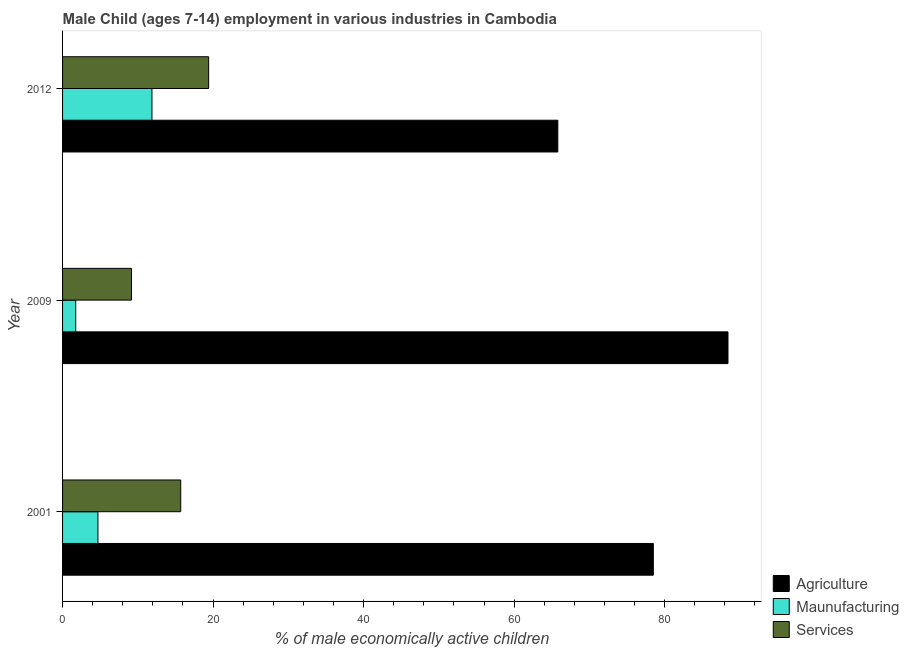How many different coloured bars are there?
Your answer should be very brief. 3. Are the number of bars on each tick of the Y-axis equal?
Make the answer very short. Yes. How many bars are there on the 2nd tick from the top?
Make the answer very short. 3. How many bars are there on the 1st tick from the bottom?
Your answer should be compact. 3. In how many cases, is the number of bars for a given year not equal to the number of legend labels?
Provide a short and direct response. 0. What is the percentage of economically active children in services in 2009?
Your answer should be very brief. 9.16. Across all years, what is the maximum percentage of economically active children in agriculture?
Keep it short and to the point. 88.42. Across all years, what is the minimum percentage of economically active children in services?
Offer a terse response. 9.16. What is the total percentage of economically active children in services in the graph?
Offer a very short reply. 44.27. What is the difference between the percentage of economically active children in manufacturing in 2001 and that in 2012?
Your response must be concise. -7.18. What is the difference between the percentage of economically active children in manufacturing in 2001 and the percentage of economically active children in services in 2009?
Provide a succinct answer. -4.46. What is the average percentage of economically active children in agriculture per year?
Provide a short and direct response. 77.58. In the year 2009, what is the difference between the percentage of economically active children in manufacturing and percentage of economically active children in agriculture?
Your answer should be very brief. -86.67. In how many years, is the percentage of economically active children in manufacturing greater than 32 %?
Make the answer very short. 0. What is the ratio of the percentage of economically active children in agriculture in 2001 to that in 2012?
Your response must be concise. 1.19. Is the percentage of economically active children in agriculture in 2001 less than that in 2009?
Your response must be concise. Yes. Is the difference between the percentage of economically active children in services in 2009 and 2012 greater than the difference between the percentage of economically active children in agriculture in 2009 and 2012?
Ensure brevity in your answer.  No. What is the difference between the highest and the second highest percentage of economically active children in services?
Your answer should be very brief. 3.71. What is the difference between the highest and the lowest percentage of economically active children in manufacturing?
Keep it short and to the point. 10.13. In how many years, is the percentage of economically active children in manufacturing greater than the average percentage of economically active children in manufacturing taken over all years?
Your answer should be compact. 1. Is the sum of the percentage of economically active children in services in 2001 and 2009 greater than the maximum percentage of economically active children in agriculture across all years?
Ensure brevity in your answer.  No. What does the 1st bar from the top in 2001 represents?
Keep it short and to the point. Services. What does the 2nd bar from the bottom in 2012 represents?
Provide a short and direct response. Maunufacturing. How many bars are there?
Offer a terse response. 9. Are all the bars in the graph horizontal?
Keep it short and to the point. Yes. Are the values on the major ticks of X-axis written in scientific E-notation?
Offer a very short reply. No. Does the graph contain any zero values?
Make the answer very short. No. Does the graph contain grids?
Give a very brief answer. No. Where does the legend appear in the graph?
Make the answer very short. Bottom right. How are the legend labels stacked?
Your answer should be compact. Vertical. What is the title of the graph?
Your response must be concise. Male Child (ages 7-14) employment in various industries in Cambodia. What is the label or title of the X-axis?
Offer a terse response. % of male economically active children. What is the label or title of the Y-axis?
Keep it short and to the point. Year. What is the % of male economically active children in Agriculture in 2001?
Your answer should be very brief. 78.5. What is the % of male economically active children of Agriculture in 2009?
Your answer should be very brief. 88.42. What is the % of male economically active children of Maunufacturing in 2009?
Offer a terse response. 1.75. What is the % of male economically active children in Services in 2009?
Provide a succinct answer. 9.16. What is the % of male economically active children of Agriculture in 2012?
Give a very brief answer. 65.81. What is the % of male economically active children of Maunufacturing in 2012?
Provide a short and direct response. 11.88. What is the % of male economically active children in Services in 2012?
Provide a short and direct response. 19.41. Across all years, what is the maximum % of male economically active children of Agriculture?
Ensure brevity in your answer.  88.42. Across all years, what is the maximum % of male economically active children in Maunufacturing?
Provide a short and direct response. 11.88. Across all years, what is the maximum % of male economically active children in Services?
Give a very brief answer. 19.41. Across all years, what is the minimum % of male economically active children in Agriculture?
Provide a succinct answer. 65.81. Across all years, what is the minimum % of male economically active children of Maunufacturing?
Make the answer very short. 1.75. Across all years, what is the minimum % of male economically active children of Services?
Give a very brief answer. 9.16. What is the total % of male economically active children in Agriculture in the graph?
Your response must be concise. 232.73. What is the total % of male economically active children in Maunufacturing in the graph?
Provide a succinct answer. 18.33. What is the total % of male economically active children of Services in the graph?
Provide a succinct answer. 44.27. What is the difference between the % of male economically active children of Agriculture in 2001 and that in 2009?
Your response must be concise. -9.92. What is the difference between the % of male economically active children in Maunufacturing in 2001 and that in 2009?
Ensure brevity in your answer.  2.95. What is the difference between the % of male economically active children of Services in 2001 and that in 2009?
Your response must be concise. 6.54. What is the difference between the % of male economically active children of Agriculture in 2001 and that in 2012?
Offer a terse response. 12.69. What is the difference between the % of male economically active children in Maunufacturing in 2001 and that in 2012?
Keep it short and to the point. -7.18. What is the difference between the % of male economically active children in Services in 2001 and that in 2012?
Make the answer very short. -3.71. What is the difference between the % of male economically active children of Agriculture in 2009 and that in 2012?
Offer a very short reply. 22.61. What is the difference between the % of male economically active children in Maunufacturing in 2009 and that in 2012?
Provide a short and direct response. -10.13. What is the difference between the % of male economically active children of Services in 2009 and that in 2012?
Offer a very short reply. -10.25. What is the difference between the % of male economically active children in Agriculture in 2001 and the % of male economically active children in Maunufacturing in 2009?
Keep it short and to the point. 76.75. What is the difference between the % of male economically active children in Agriculture in 2001 and the % of male economically active children in Services in 2009?
Give a very brief answer. 69.34. What is the difference between the % of male economically active children of Maunufacturing in 2001 and the % of male economically active children of Services in 2009?
Ensure brevity in your answer.  -4.46. What is the difference between the % of male economically active children in Agriculture in 2001 and the % of male economically active children in Maunufacturing in 2012?
Give a very brief answer. 66.62. What is the difference between the % of male economically active children in Agriculture in 2001 and the % of male economically active children in Services in 2012?
Keep it short and to the point. 59.09. What is the difference between the % of male economically active children in Maunufacturing in 2001 and the % of male economically active children in Services in 2012?
Your answer should be very brief. -14.71. What is the difference between the % of male economically active children of Agriculture in 2009 and the % of male economically active children of Maunufacturing in 2012?
Your response must be concise. 76.54. What is the difference between the % of male economically active children of Agriculture in 2009 and the % of male economically active children of Services in 2012?
Make the answer very short. 69.01. What is the difference between the % of male economically active children of Maunufacturing in 2009 and the % of male economically active children of Services in 2012?
Give a very brief answer. -17.66. What is the average % of male economically active children of Agriculture per year?
Your answer should be compact. 77.58. What is the average % of male economically active children of Maunufacturing per year?
Offer a terse response. 6.11. What is the average % of male economically active children in Services per year?
Make the answer very short. 14.76. In the year 2001, what is the difference between the % of male economically active children of Agriculture and % of male economically active children of Maunufacturing?
Offer a very short reply. 73.8. In the year 2001, what is the difference between the % of male economically active children in Agriculture and % of male economically active children in Services?
Offer a terse response. 62.8. In the year 2001, what is the difference between the % of male economically active children of Maunufacturing and % of male economically active children of Services?
Your response must be concise. -11. In the year 2009, what is the difference between the % of male economically active children in Agriculture and % of male economically active children in Maunufacturing?
Ensure brevity in your answer.  86.67. In the year 2009, what is the difference between the % of male economically active children in Agriculture and % of male economically active children in Services?
Provide a short and direct response. 79.26. In the year 2009, what is the difference between the % of male economically active children of Maunufacturing and % of male economically active children of Services?
Provide a succinct answer. -7.41. In the year 2012, what is the difference between the % of male economically active children of Agriculture and % of male economically active children of Maunufacturing?
Your answer should be very brief. 53.93. In the year 2012, what is the difference between the % of male economically active children of Agriculture and % of male economically active children of Services?
Ensure brevity in your answer.  46.4. In the year 2012, what is the difference between the % of male economically active children of Maunufacturing and % of male economically active children of Services?
Your response must be concise. -7.53. What is the ratio of the % of male economically active children in Agriculture in 2001 to that in 2009?
Make the answer very short. 0.89. What is the ratio of the % of male economically active children of Maunufacturing in 2001 to that in 2009?
Provide a short and direct response. 2.69. What is the ratio of the % of male economically active children of Services in 2001 to that in 2009?
Offer a terse response. 1.71. What is the ratio of the % of male economically active children in Agriculture in 2001 to that in 2012?
Ensure brevity in your answer.  1.19. What is the ratio of the % of male economically active children of Maunufacturing in 2001 to that in 2012?
Provide a succinct answer. 0.4. What is the ratio of the % of male economically active children of Services in 2001 to that in 2012?
Provide a succinct answer. 0.81. What is the ratio of the % of male economically active children in Agriculture in 2009 to that in 2012?
Offer a terse response. 1.34. What is the ratio of the % of male economically active children of Maunufacturing in 2009 to that in 2012?
Offer a very short reply. 0.15. What is the ratio of the % of male economically active children in Services in 2009 to that in 2012?
Provide a succinct answer. 0.47. What is the difference between the highest and the second highest % of male economically active children of Agriculture?
Give a very brief answer. 9.92. What is the difference between the highest and the second highest % of male economically active children in Maunufacturing?
Provide a short and direct response. 7.18. What is the difference between the highest and the second highest % of male economically active children of Services?
Ensure brevity in your answer.  3.71. What is the difference between the highest and the lowest % of male economically active children of Agriculture?
Your answer should be compact. 22.61. What is the difference between the highest and the lowest % of male economically active children of Maunufacturing?
Your response must be concise. 10.13. What is the difference between the highest and the lowest % of male economically active children of Services?
Provide a short and direct response. 10.25. 